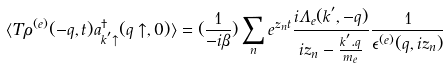<formula> <loc_0><loc_0><loc_500><loc_500>\langle T \rho ^ { ( e ) } ( - { q } , t ) a ^ { \dagger } _ { { k } ^ { ^ { \prime } } \uparrow } ( { q } \uparrow , 0 ) \rangle = ( \frac { 1 } { - i \beta } ) \sum _ { n } e ^ { z _ { n } t } \frac { i \Lambda _ { e } ( { k } ^ { ^ { \prime } } , - { q } ) } { i z _ { n } - \frac { { k } ^ { ^ { \prime } } . { q } } { m _ { e } } } \frac { 1 } { \epsilon ^ { ( e ) } ( { q } , i z _ { n } ) }</formula> 